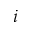Convert formula to latex. <formula><loc_0><loc_0><loc_500><loc_500>_ { i }</formula> 